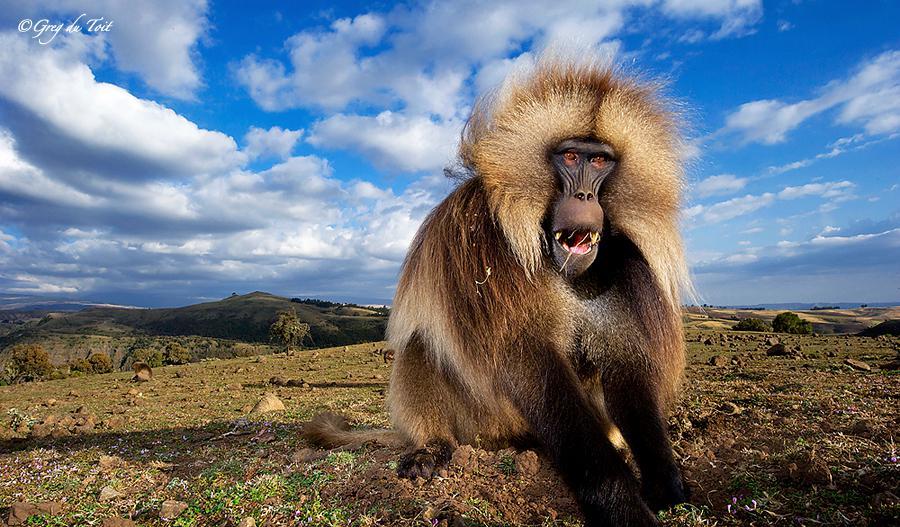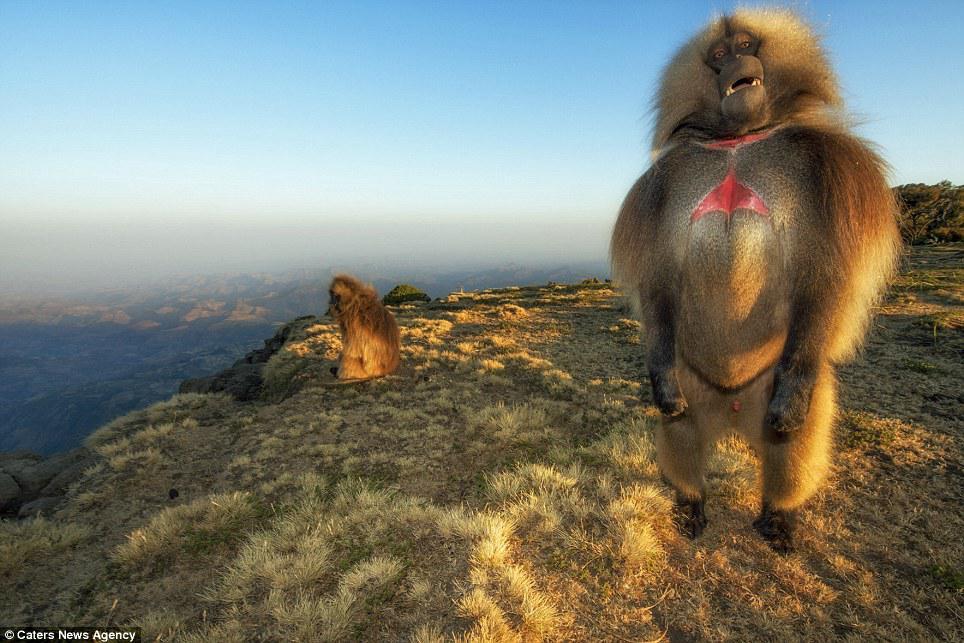The first image is the image on the left, the second image is the image on the right. Examine the images to the left and right. Is the description "There is a total of 1 baboon eating while sitting down." accurate? Answer yes or no. No. The first image is the image on the left, the second image is the image on the right. Analyze the images presented: Is the assertion "in the right pic the fangs of the monkey is shown" valid? Answer yes or no. No. 